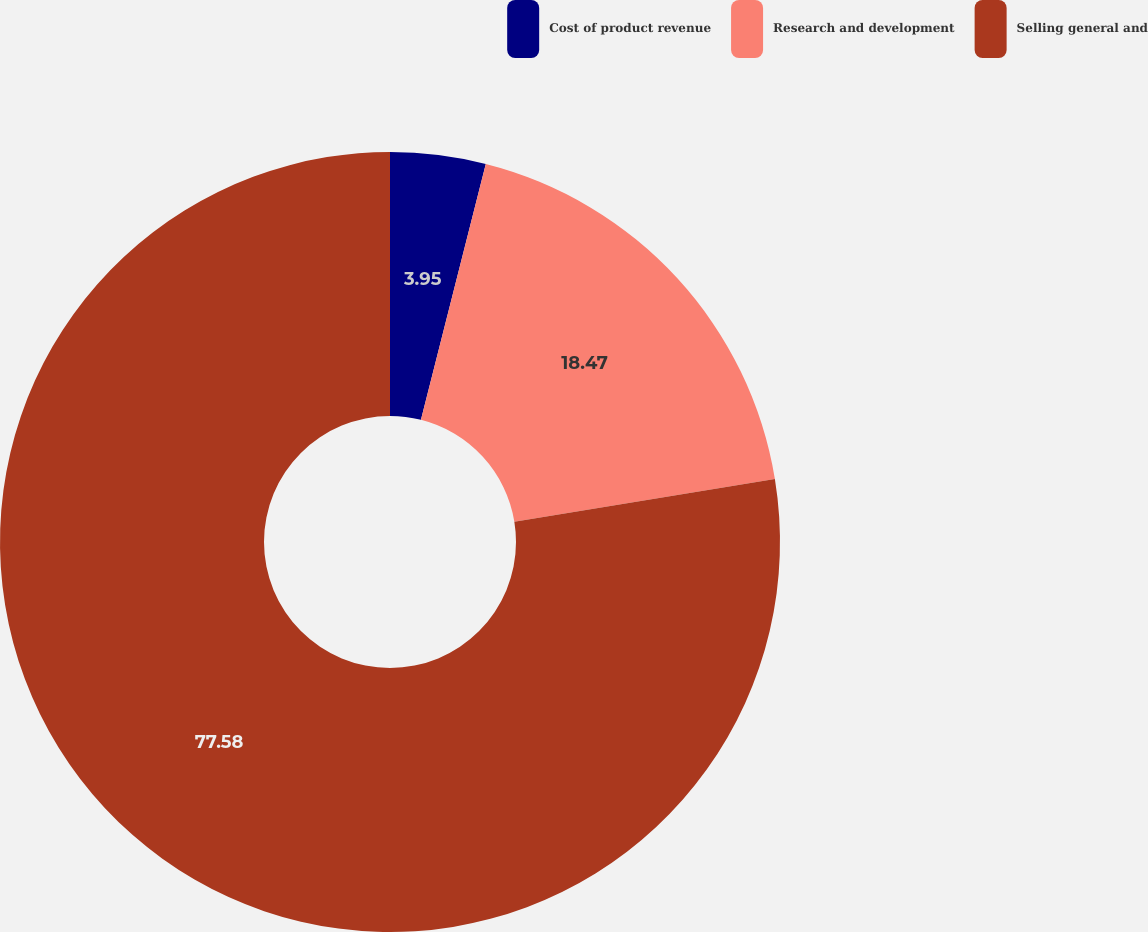<chart> <loc_0><loc_0><loc_500><loc_500><pie_chart><fcel>Cost of product revenue<fcel>Research and development<fcel>Selling general and<nl><fcel>3.95%<fcel>18.47%<fcel>77.59%<nl></chart> 